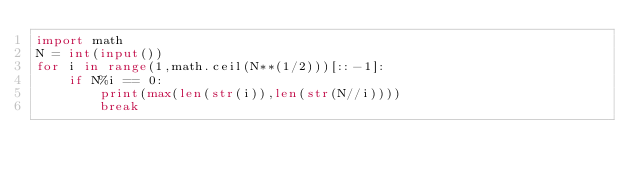<code> <loc_0><loc_0><loc_500><loc_500><_Python_>import math
N = int(input())
for i in range(1,math.ceil(N**(1/2)))[::-1]:
    if N%i == 0:
        print(max(len(str(i)),len(str(N//i))))
        break</code> 